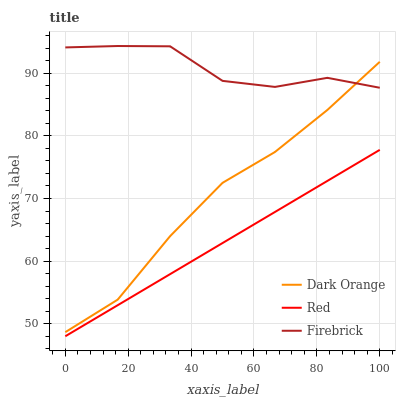Does Red have the minimum area under the curve?
Answer yes or no. Yes. Does Firebrick have the maximum area under the curve?
Answer yes or no. Yes. Does Firebrick have the minimum area under the curve?
Answer yes or no. No. Does Red have the maximum area under the curve?
Answer yes or no. No. Is Red the smoothest?
Answer yes or no. Yes. Is Firebrick the roughest?
Answer yes or no. Yes. Is Firebrick the smoothest?
Answer yes or no. No. Is Red the roughest?
Answer yes or no. No. Does Red have the lowest value?
Answer yes or no. Yes. Does Firebrick have the lowest value?
Answer yes or no. No. Does Firebrick have the highest value?
Answer yes or no. Yes. Does Red have the highest value?
Answer yes or no. No. Is Red less than Firebrick?
Answer yes or no. Yes. Is Dark Orange greater than Red?
Answer yes or no. Yes. Does Dark Orange intersect Firebrick?
Answer yes or no. Yes. Is Dark Orange less than Firebrick?
Answer yes or no. No. Is Dark Orange greater than Firebrick?
Answer yes or no. No. Does Red intersect Firebrick?
Answer yes or no. No. 